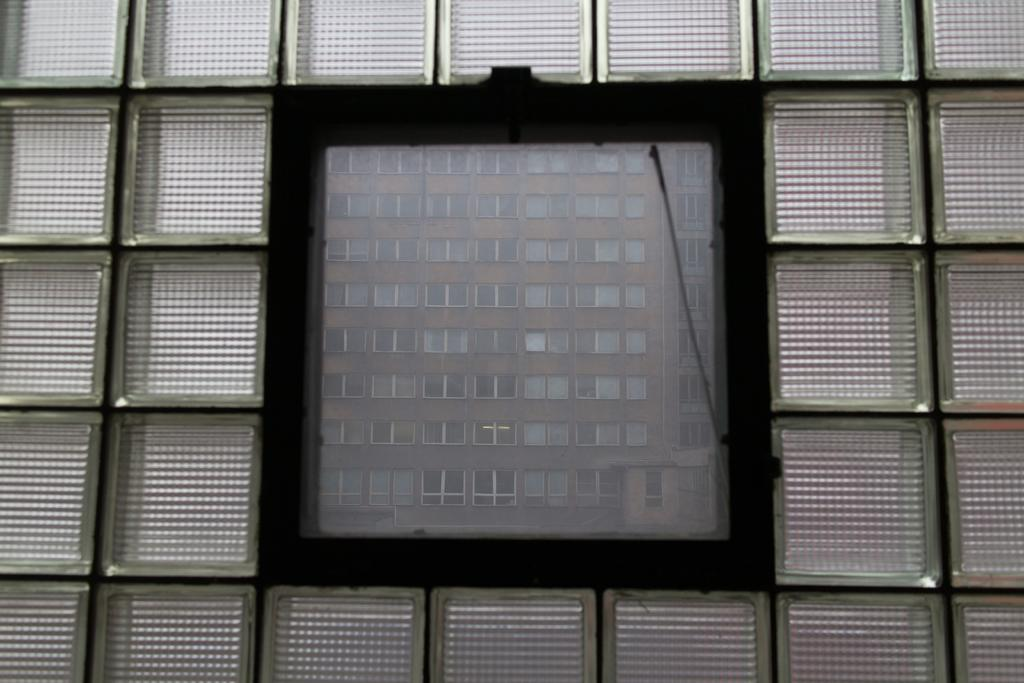What type of door is shown in the image? The image appears to show a glass door. What can be seen in the reflection on the glass door? There is a reflection of a building with windows visible in the image. What type of insect is crawling on the page in the image? There is no insect or page present in the image; it only shows a glass door with a reflection of a building. 